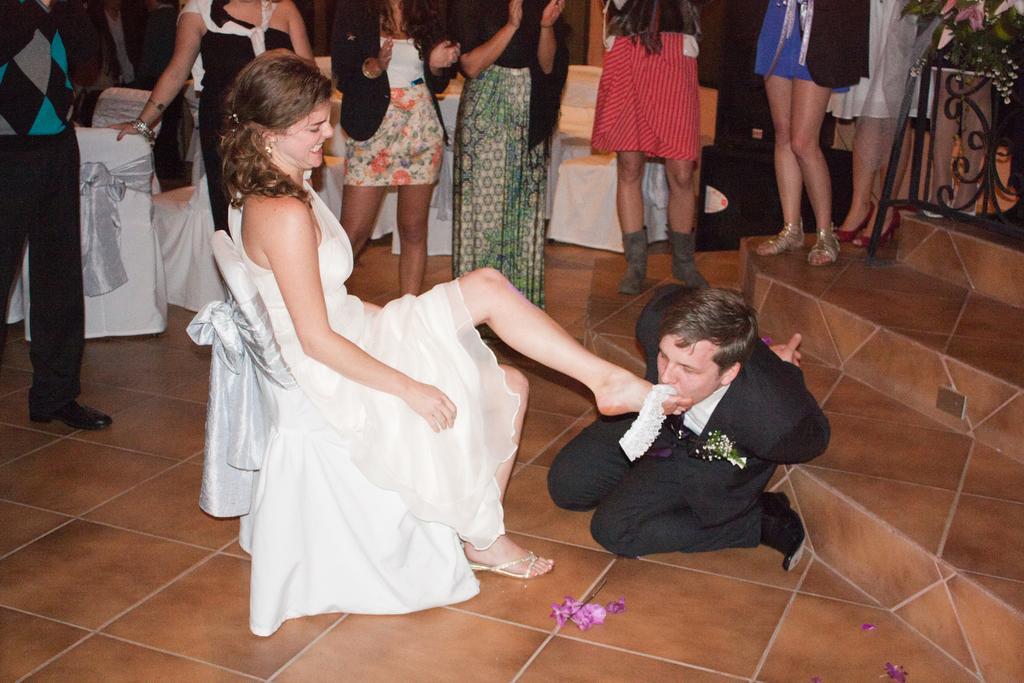Could you give a brief overview of what you see in this image? On the left side, there is a woman in white color dress, smiling and sitting on a chair. On the right side, there is a person in a suit kneeling down on the floor and keeping his face at the feet of the woman who is in front of him. In the background, there are persons standing and there are chairs arranged. And the background is dark in color. 